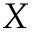<formula> <loc_0><loc_0><loc_500><loc_500>X</formula> 